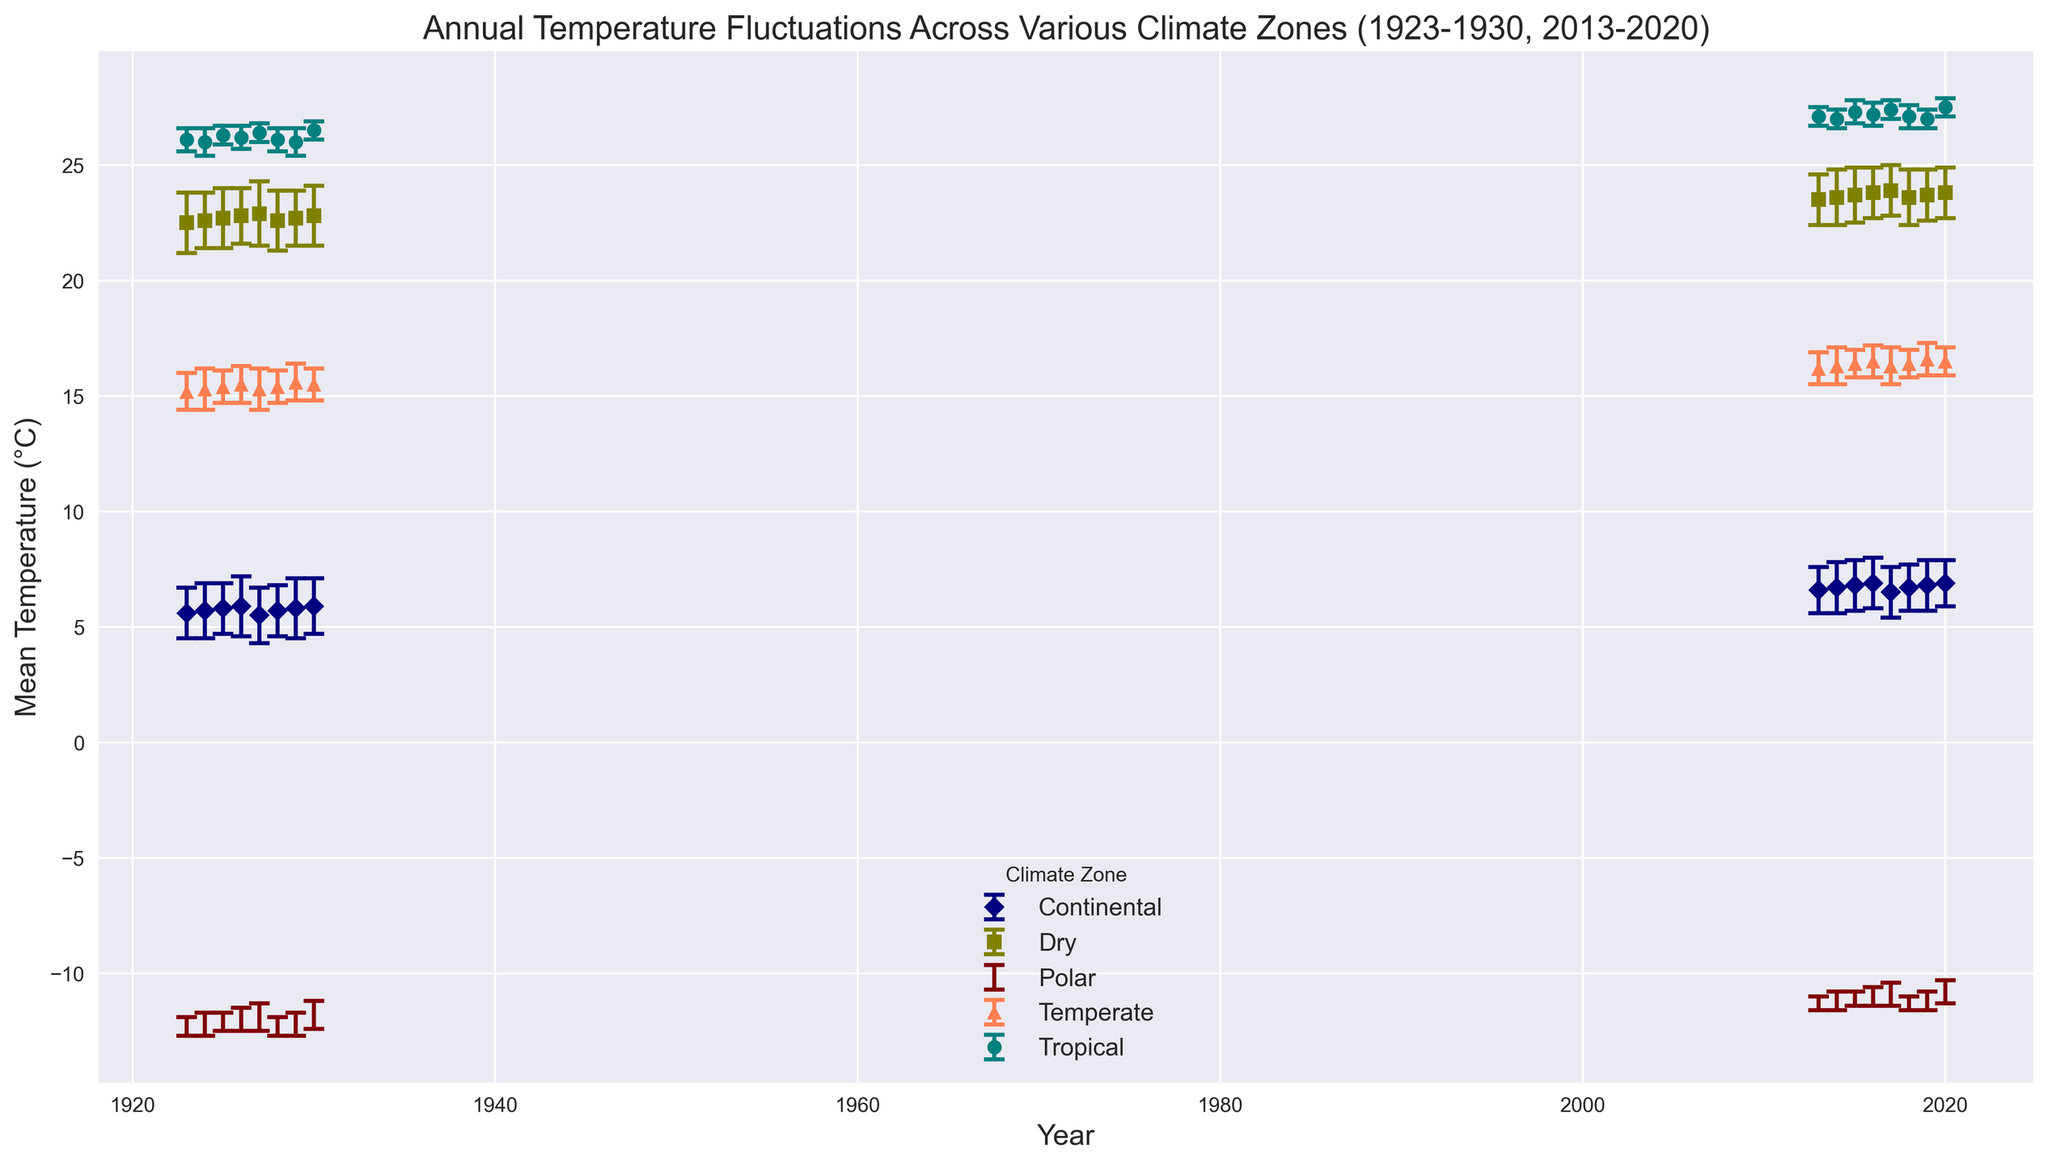Which climate zone had the highest mean temperature in 1927? To find this, we should examine the plotted mean temperature for each climate zone in 1927. We find that the highest mean temperature is for the Tropical climate zone at around 26.4°C.
Answer: Tropical What was the average mean temperature for the Polar climate zone from 2013 to 2020? To compute this, we sum the mean temperatures for the Polar climate zone from 2013 to 2020 and divide by the number of years. The summed temperature is (-11.3 + -11.2 + -11.1 + -11.0 + -10.9 + -11.3 + -11.2 + -10.8) = -89.8 °C, and the average is -89.8 / 8 = -11.225 °C.
Answer: -11.225°C Which climate zone shows the largest temperature fluctuation (standard deviation) in 1923? Looking at the error bars in 1923, the Dry climate zone shows the largest spread, indicating the largest standard deviation of around 1.3.
Answer: Dry How did the mean temperature for the Temperate climate zone change from 1923 to 2020? We observe the plotted points for the Temperate climate zone in these years. In 1923, the mean temperature was around 15.2°C, and by 2020, it was around 16.5°C. This indicates an increase of 1.3°C.
Answer: Increased by 1.3°C Compare the standard deviations of the Continental climate zone in 1930 and 2015. Which year had a higher variation? By checking the error bars, we find that in 1930 the standard deviation is around 1.2, whereas in 2015 it is around 1.1. Thus, 1930 had a higher variation.
Answer: 1930 What is the range of mean temperatures for the Dry climate zone in 1923-1930? We find the maximum mean temperature for the Dry climate zone in 1923-1930 is around 22.9°C in 1927, and the minimum is around 22.5°C in 1923. The range is 22.9 - 22.5 = 0.4°C.
Answer: 0.4°C Between 2013 and 2020, which climate zone had the most stable mean temperature (smallest standard deviation)? The most stable temperature would correspond to the smallest error bars. Observing the plot, the Polar climate zone had the smallest error bars around 0.3 to 0.5, indicating the most stability.
Answer: Polar What is the difference in mean temperatures between the Continental climate zone in 1925 and 2019? From the plot, the mean temperature for the Continental zone in 1925 was about 5.8°C and in 2019 was about 6.8°C. The difference is 6.8 - 5.8 = 1.0°C.
Answer: 1.0°C 